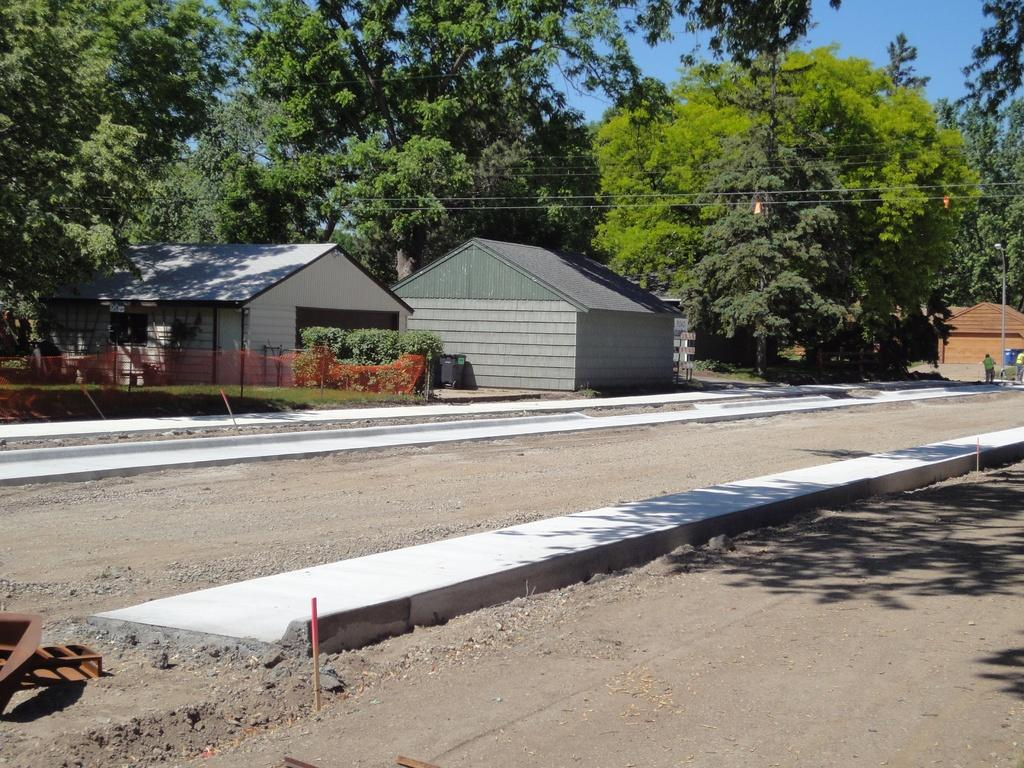What type of structures can be seen in the image? There are buildings in the image. What object is present that might be used for catching or holding? There is a net in the image. What type of vegetation is present in the image? There are bushes and trees in the image. What type of waste disposal containers are visible in the image? There are bins in the image. What type of ground surface is present in the image? There is grass in the image. Can you describe the person in the image? There is a person on the road in the image. What type of vertical structure is present in the image? There is a street pole in the image. What type of lighting is present in the image? There are street lights in the image. What type of infrastructure is present in the image? There are electric cables in the image. What part of the natural environment is visible in the image? The sky is visible in the image. What type of jeans is the person wearing in the image? There is no information about the person's clothing in the image, so we cannot determine if they are wearing jeans or any other type of clothing. How does the person in the image grip the street pole? There is no indication that the person is gripping the street pole in the image. 